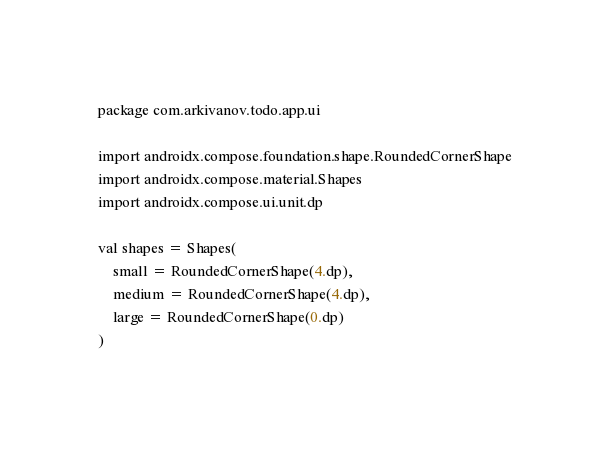<code> <loc_0><loc_0><loc_500><loc_500><_Kotlin_>package com.arkivanov.todo.app.ui

import androidx.compose.foundation.shape.RoundedCornerShape
import androidx.compose.material.Shapes
import androidx.compose.ui.unit.dp

val shapes = Shapes(
    small = RoundedCornerShape(4.dp),
    medium = RoundedCornerShape(4.dp),
    large = RoundedCornerShape(0.dp)
)</code> 